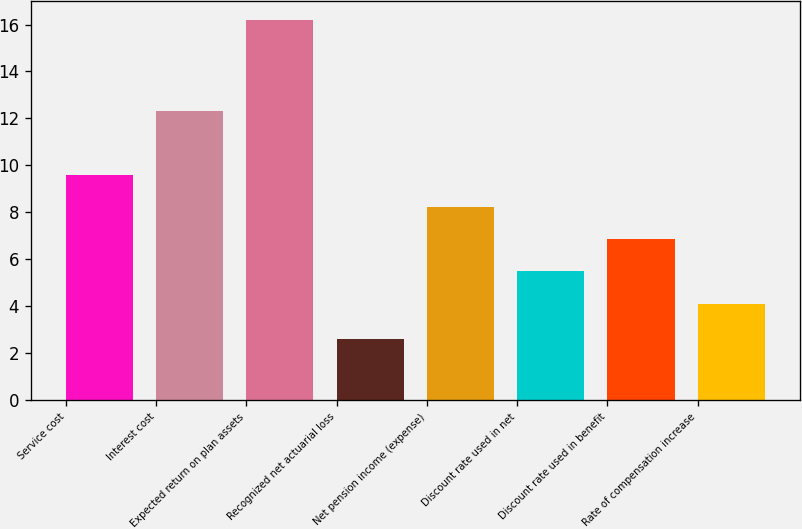Convert chart. <chart><loc_0><loc_0><loc_500><loc_500><bar_chart><fcel>Service cost<fcel>Interest cost<fcel>Expected return on plan assets<fcel>Recognized net actuarial loss<fcel>Net pension income (expense)<fcel>Discount rate used in net<fcel>Discount rate used in benefit<fcel>Rate of compensation increase<nl><fcel>9.58<fcel>12.3<fcel>16.2<fcel>2.6<fcel>8.22<fcel>5.5<fcel>6.86<fcel>4.1<nl></chart> 